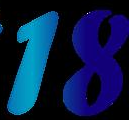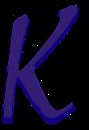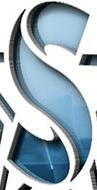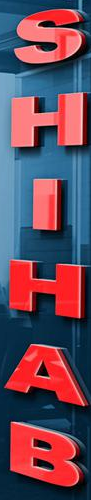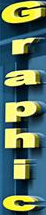What words are shown in these images in order, separated by a semicolon? 18; k; S; SHIHAB; Graphic 